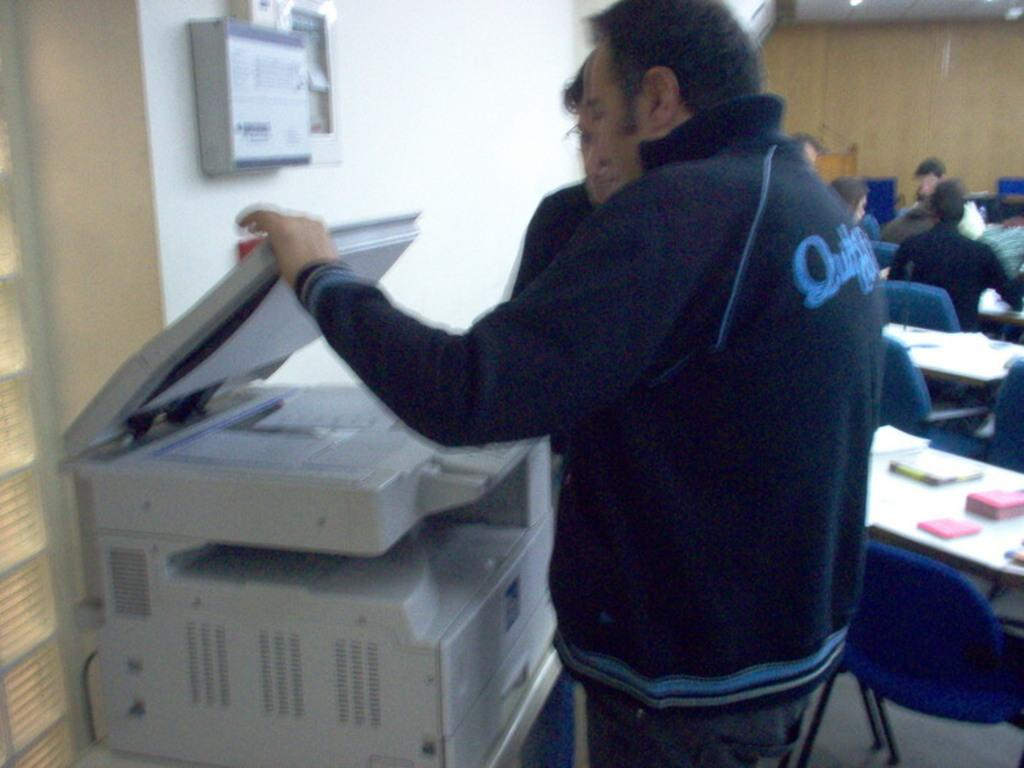How many people are visible in the image? There are two people standing in the image. What are the two people looking at? The two people are looking at a printer. Can you describe the people in the background of the image? There are more people sitting in the background of the image. What type of dolls can be seen playing in the yard in the image? There are no dolls or yard present in the image; it features two people looking at a printer and additional people sitting in the background. 